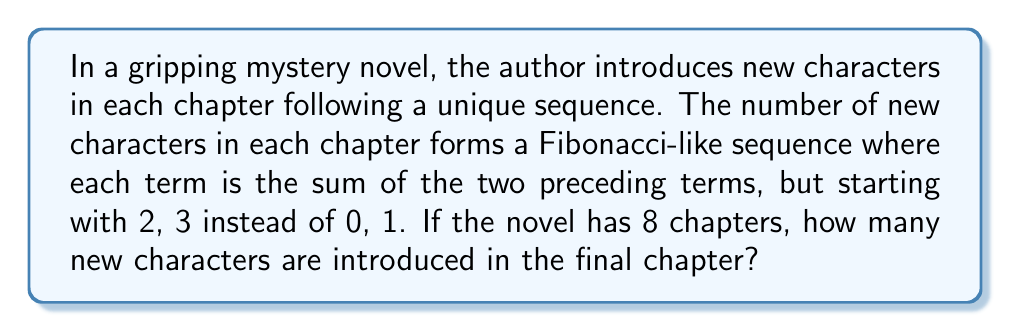Provide a solution to this math problem. Let's approach this step-by-step:

1) First, let's write out the sequence for the 8 chapters:

   Chapter 1: 2
   Chapter 2: 3
   Chapter 3: $2 + 3 = 5$
   Chapter 4: $3 + 5 = 8$
   Chapter 5: $5 + 8 = 13$
   Chapter 6: $8 + 13 = 21$
   Chapter 7: $13 + 21 = 34$
   Chapter 8: $21 + 34 = 55$

2) We can represent this sequence mathematically as:

   $a_n = a_{n-1} + a_{n-2}$ for $n \geq 3$

   Where $a_1 = 2$ and $a_2 = 3$

3) To find the number of new characters in the 8th chapter, we need to calculate $a_8$:

   $a_8 = a_7 + a_6 = 34 + 21 = 55$

Therefore, 55 new characters are introduced in the final (8th) chapter of the novel.
Answer: 55 